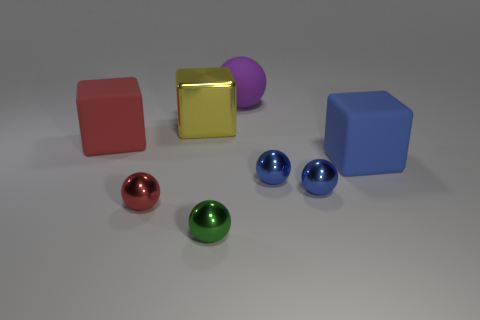What number of green things are either matte things or small balls?
Your answer should be very brief. 1. There is a block that is in front of the large red thing; what is it made of?
Provide a short and direct response. Rubber. There is a big matte thing that is behind the big red matte block; what number of big blue rubber things are behind it?
Keep it short and to the point. 0. How many other small metallic objects are the same shape as the yellow object?
Make the answer very short. 0. What number of purple rubber objects are there?
Provide a short and direct response. 1. The large rubber thing to the left of the large purple ball is what color?
Give a very brief answer. Red. The big cube that is behind the big rubber block on the left side of the large purple sphere is what color?
Keep it short and to the point. Yellow. What color is the metallic thing that is the same size as the purple ball?
Offer a terse response. Yellow. What number of objects are both on the left side of the big ball and behind the blue block?
Provide a short and direct response. 2. What is the material of the big thing that is both left of the matte sphere and to the right of the red metallic thing?
Keep it short and to the point. Metal. 